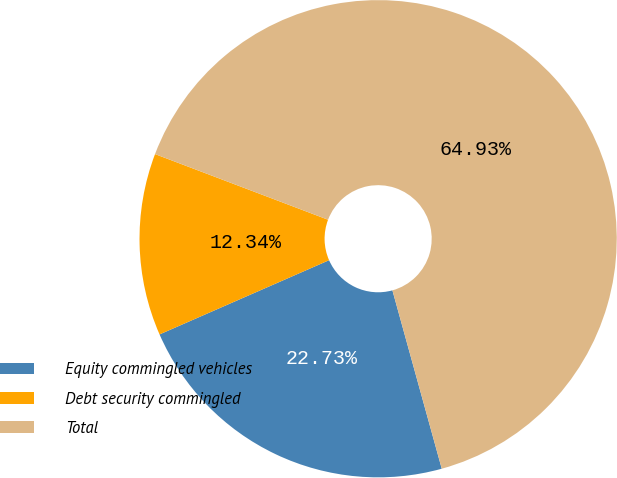<chart> <loc_0><loc_0><loc_500><loc_500><pie_chart><fcel>Equity commingled vehicles<fcel>Debt security commingled<fcel>Total<nl><fcel>22.73%<fcel>12.34%<fcel>64.94%<nl></chart> 